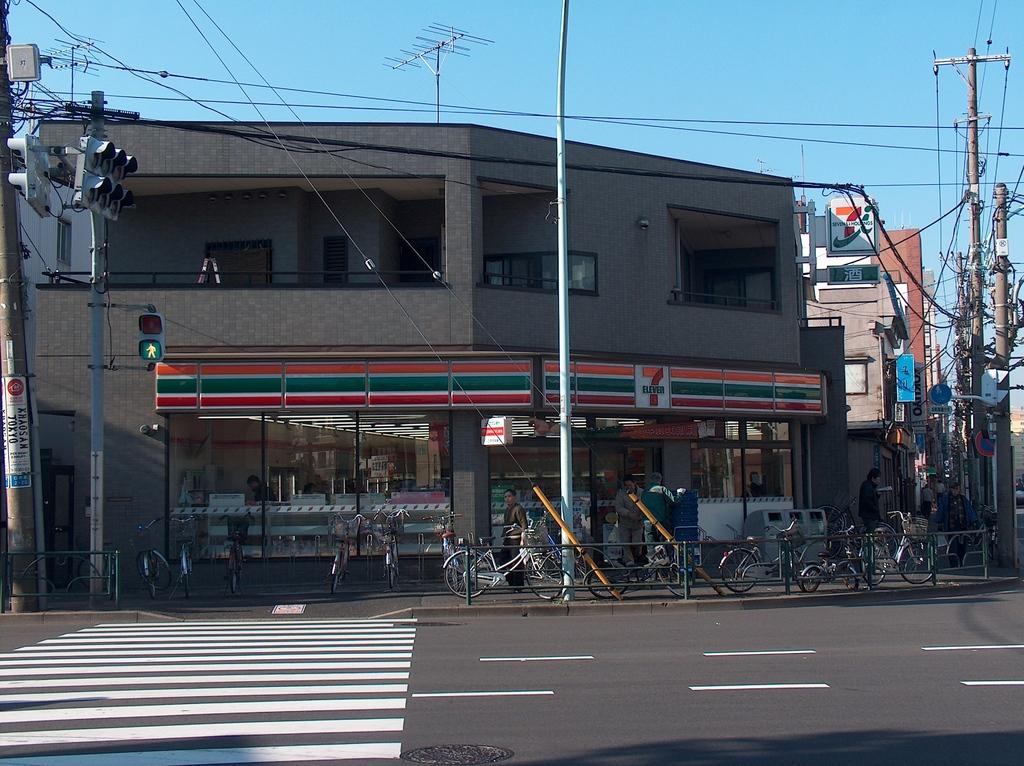What store is that?
Keep it short and to the point. 7 eleven. 